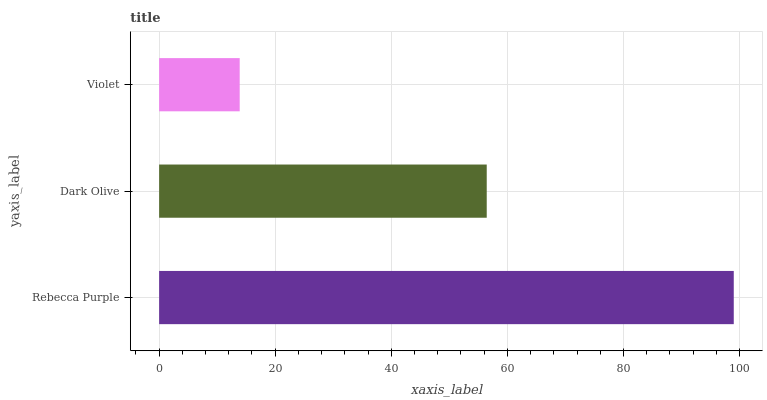Is Violet the minimum?
Answer yes or no. Yes. Is Rebecca Purple the maximum?
Answer yes or no. Yes. Is Dark Olive the minimum?
Answer yes or no. No. Is Dark Olive the maximum?
Answer yes or no. No. Is Rebecca Purple greater than Dark Olive?
Answer yes or no. Yes. Is Dark Olive less than Rebecca Purple?
Answer yes or no. Yes. Is Dark Olive greater than Rebecca Purple?
Answer yes or no. No. Is Rebecca Purple less than Dark Olive?
Answer yes or no. No. Is Dark Olive the high median?
Answer yes or no. Yes. Is Dark Olive the low median?
Answer yes or no. Yes. Is Violet the high median?
Answer yes or no. No. Is Rebecca Purple the low median?
Answer yes or no. No. 